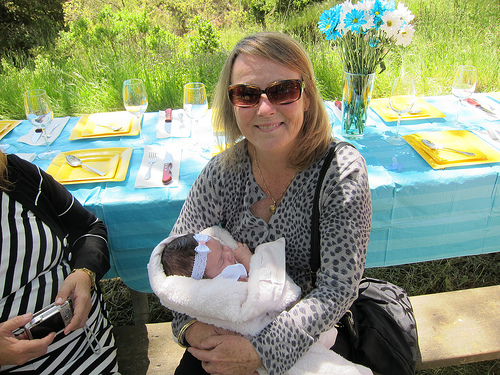<image>
Is the mother behind the baby? No. The mother is not behind the baby. From this viewpoint, the mother appears to be positioned elsewhere in the scene. 